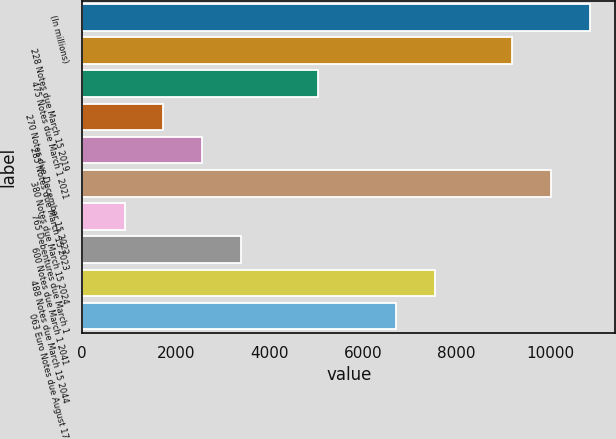Convert chart to OTSL. <chart><loc_0><loc_0><loc_500><loc_500><bar_chart><fcel>(In millions)<fcel>228 Notes due March 15 2019<fcel>475 Notes due March 1 2021<fcel>270 Notes due December 15 2022<fcel>285 Notes due March 15 2023<fcel>380 Notes due March 15 2024<fcel>765 Debentures due March 1<fcel>600 Notes due March 1 2041<fcel>488 Notes due March 15 2044<fcel>063 Euro Notes due August 17<nl><fcel>10848.1<fcel>9190.7<fcel>5047.2<fcel>1732.4<fcel>2561.1<fcel>10019.4<fcel>903.7<fcel>3389.8<fcel>7533.3<fcel>6704.6<nl></chart> 